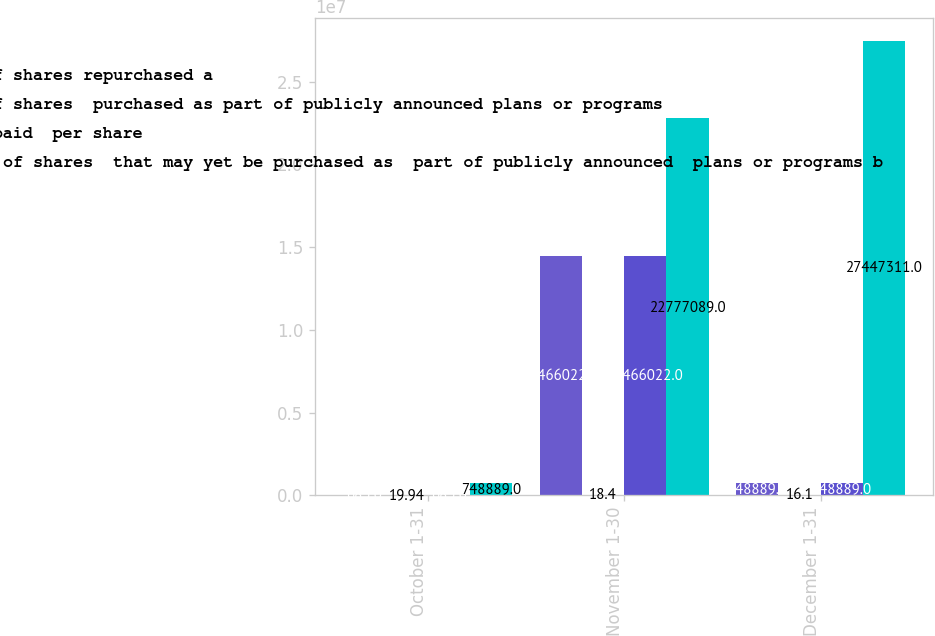<chart> <loc_0><loc_0><loc_500><loc_500><stacked_bar_chart><ecel><fcel>October 1-31<fcel>November 1-30<fcel>December 1-31<nl><fcel>Total number of shares repurchased a<fcel>683<fcel>1.4466e+07<fcel>748889<nl><fcel>Total number of shares  purchased as part of publicly announced plans or programs<fcel>19.94<fcel>18.4<fcel>16.1<nl><fcel>Average price paid  per share<fcel>683<fcel>1.4466e+07<fcel>748889<nl><fcel>Maximum number of shares  that may yet be purchased as  part of publicly announced  plans or programs b<fcel>748889<fcel>2.27771e+07<fcel>2.74473e+07<nl></chart> 